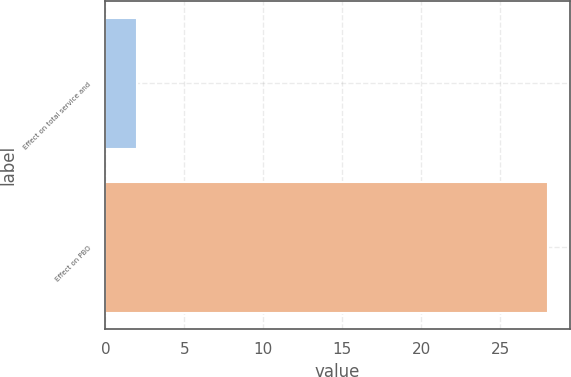Convert chart. <chart><loc_0><loc_0><loc_500><loc_500><bar_chart><fcel>Effect on total service and<fcel>Effect on PBO<nl><fcel>2<fcel>28<nl></chart> 